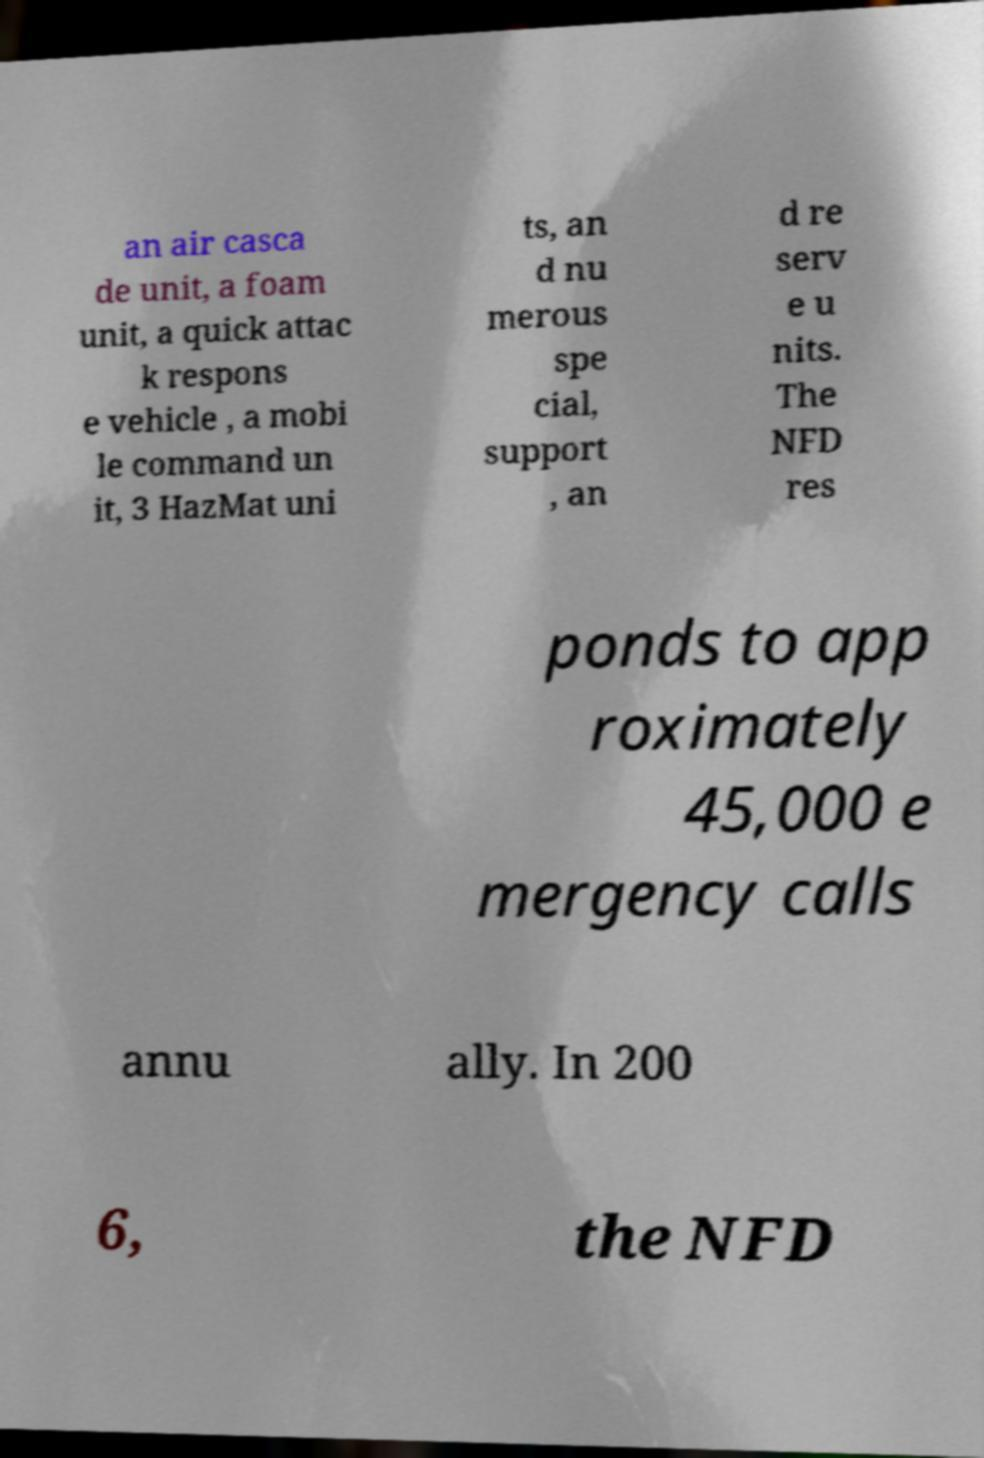Please identify and transcribe the text found in this image. an air casca de unit, a foam unit, a quick attac k respons e vehicle , a mobi le command un it, 3 HazMat uni ts, an d nu merous spe cial, support , an d re serv e u nits. The NFD res ponds to app roximately 45,000 e mergency calls annu ally. In 200 6, the NFD 